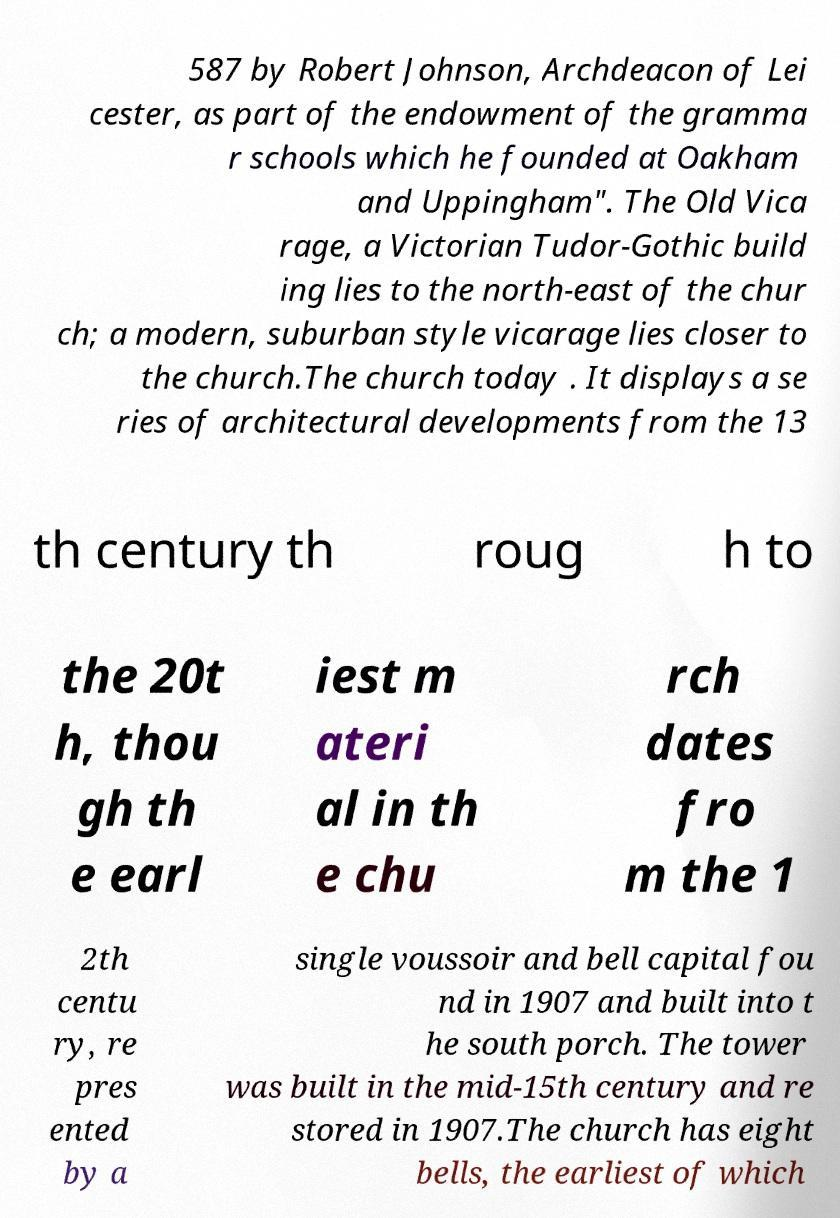I need the written content from this picture converted into text. Can you do that? 587 by Robert Johnson, Archdeacon of Lei cester, as part of the endowment of the gramma r schools which he founded at Oakham and Uppingham". The Old Vica rage, a Victorian Tudor-Gothic build ing lies to the north-east of the chur ch; a modern, suburban style vicarage lies closer to the church.The church today . It displays a se ries of architectural developments from the 13 th century th roug h to the 20t h, thou gh th e earl iest m ateri al in th e chu rch dates fro m the 1 2th centu ry, re pres ented by a single voussoir and bell capital fou nd in 1907 and built into t he south porch. The tower was built in the mid-15th century and re stored in 1907.The church has eight bells, the earliest of which 